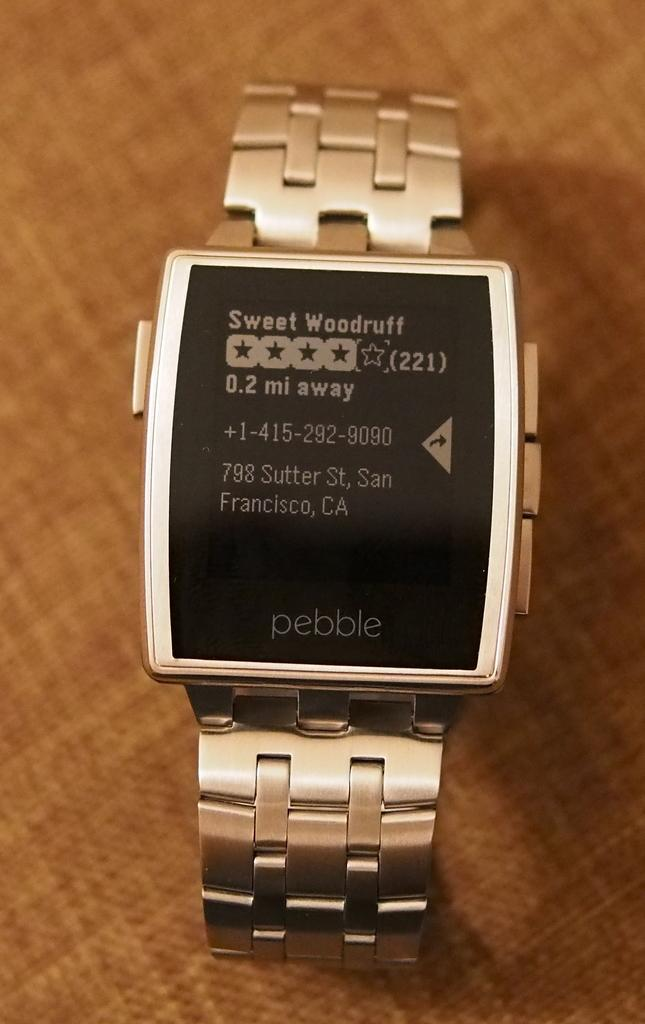<image>
Share a concise interpretation of the image provided. A Pebble watch display says Sweet Woodruff on it 